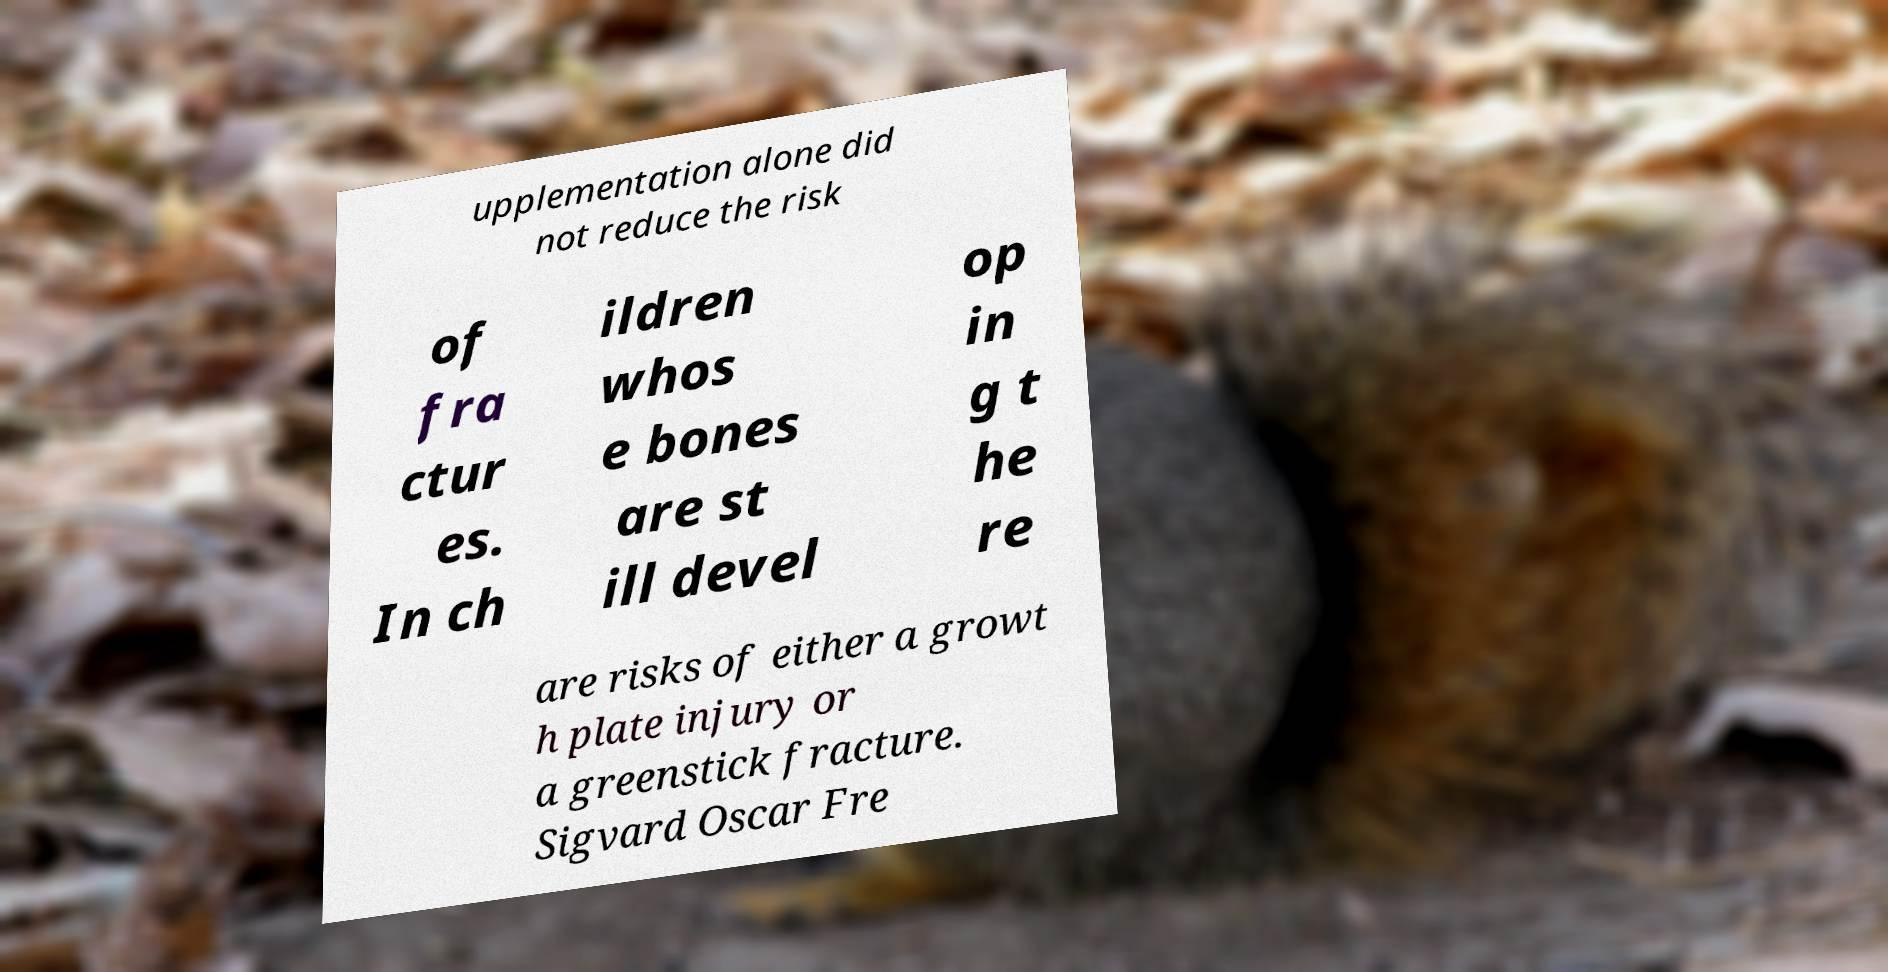Could you assist in decoding the text presented in this image and type it out clearly? upplementation alone did not reduce the risk of fra ctur es. In ch ildren whos e bones are st ill devel op in g t he re are risks of either a growt h plate injury or a greenstick fracture. Sigvard Oscar Fre 